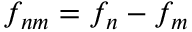Convert formula to latex. <formula><loc_0><loc_0><loc_500><loc_500>f _ { n m } = f _ { n } - f _ { m }</formula> 